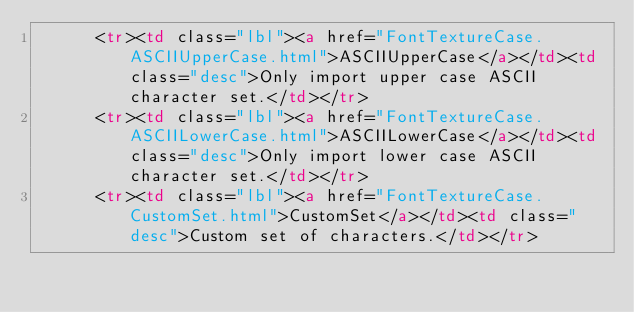Convert code to text. <code><loc_0><loc_0><loc_500><loc_500><_HTML_>      <tr><td class="lbl"><a href="FontTextureCase.ASCIIUpperCase.html">ASCIIUpperCase</a></td><td class="desc">Only import upper case ASCII character set.</td></tr>
      <tr><td class="lbl"><a href="FontTextureCase.ASCIILowerCase.html">ASCIILowerCase</a></td><td class="desc">Only import lower case ASCII character set.</td></tr>
      <tr><td class="lbl"><a href="FontTextureCase.CustomSet.html">CustomSet</a></td><td class="desc">Custom set of characters.</td></tr></code> 